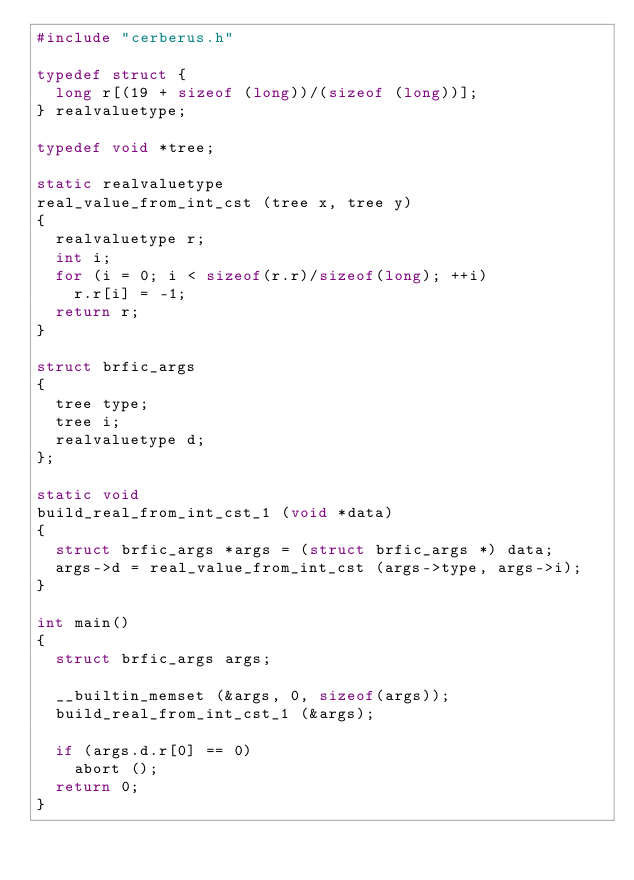Convert code to text. <code><loc_0><loc_0><loc_500><loc_500><_C_>#include "cerberus.h"

typedef struct {
  long r[(19 + sizeof (long))/(sizeof (long))];
} realvaluetype;

typedef void *tree;

static realvaluetype
real_value_from_int_cst (tree x, tree y)
{
  realvaluetype r;
  int i;
  for (i = 0; i < sizeof(r.r)/sizeof(long); ++i)
    r.r[i] = -1;
  return r;
}

struct brfic_args
{
  tree type;
  tree i;
  realvaluetype d;
};

static void
build_real_from_int_cst_1 (void *data)
{
  struct brfic_args *args = (struct brfic_args *) data;
  args->d = real_value_from_int_cst (args->type, args->i);
}

int main()
{
  struct brfic_args args;

  __builtin_memset (&args, 0, sizeof(args));
  build_real_from_int_cst_1 (&args);

  if (args.d.r[0] == 0)
    abort ();
  return 0;
}
</code> 